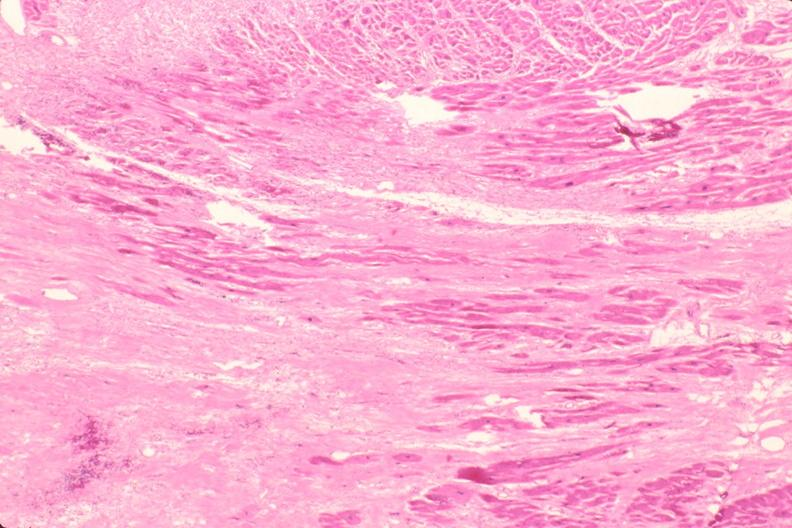s omphalocele present?
Answer the question using a single word or phrase. No 